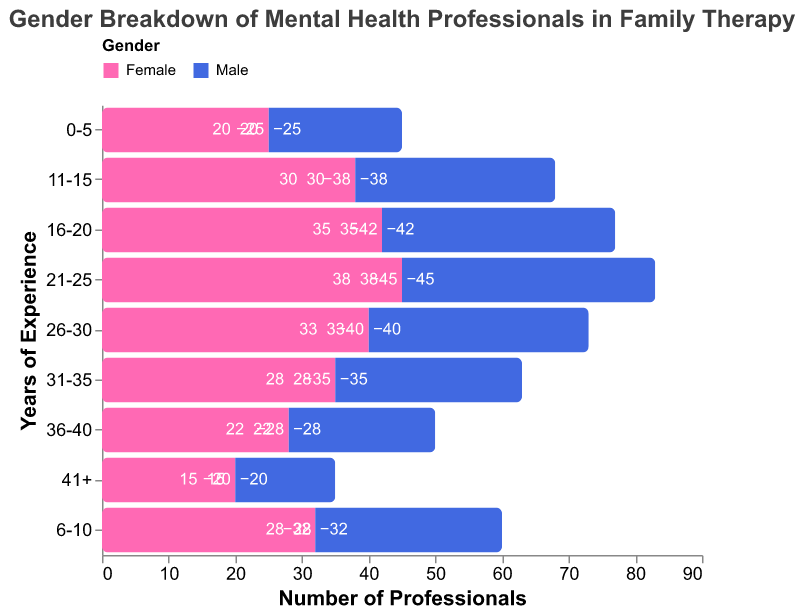What is the title of the figure? The title of the figure is stated at the top of the plot.
Answer: Gender Breakdown of Mental Health Professionals in Family Therapy Which gender has the highest number of professionals with 21-25 years of experience? By looking at the bar lengths for the 21-25 years of experience, the male bar is taller than the female bar.
Answer: Male How many female mental health professionals have 0-5 years of experience? The value corresponding to the 0-5 years experience category for females is -25. This indicates 25 professionals.
Answer: 25 How does the number of male professionals with 16-20 years of experience compare to those with 31-35 years of experience? According to the figure, males with 16-20 years of experience are 35, while those with 31-35 years of experience are 28. So, the number is greater for 16-20 years.
Answer: Greater for 16-20 years What is the total number of mental health professionals with 41+ years of experience across both genders? The professionals with 41+ years of experience are -20 females and 15 males, which adds up to 20 + 15 = 35.
Answer: 35 Which gender has a decreasing trend in the number of professionals with increasing years of experience from 21-25 years onwards? From the plot, females show a decreasing trend from 21-25 years (45) to 41+ years (20), while males also decrease but less dramatically. Hence, females show a stronger decreasing trend.
Answer: Female What are the average numbers of female and male professionals across all experience categories? Sum the values for each gender separately and divide by the number of categories (9).
For females: (-25 - 32 - 38 - 42 - 45 - 40 - 35 - 28 - 20) / 9 = -305 / 9 ≈ -33.9.
For males: (20 + 28 + 30 + 35 + 38 + 33 + 28 + 22 + 15) / 9 = 249 / 9 ≈ 27.7.
Answer: -33.9 for females, 27.7 for males Which gender has the most professionals in the 11-15 years of experience category? From the plot, comparing the lengths of the bars for males and females in the 11-15 years experience category, the female bar is longer (38 females vs 30 males).
Answer: Female How much more male professionals are there compared to female professionals in the 0-5 years category? The values are -25 for females and 20 for males. The difference is 20 - (-25) = 45.
Answer: 45 